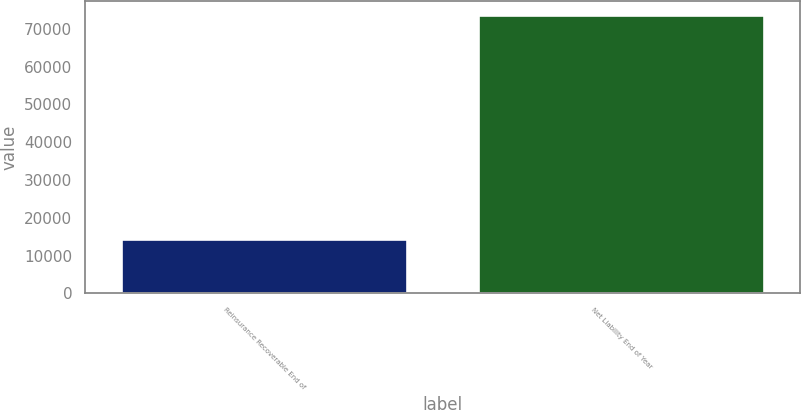Convert chart. <chart><loc_0><loc_0><loc_500><loc_500><bar_chart><fcel>Reinsurance Recoverable End of<fcel>Net Liability End of Year<nl><fcel>14337<fcel>73636<nl></chart> 